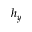<formula> <loc_0><loc_0><loc_500><loc_500>h _ { y }</formula> 